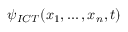<formula> <loc_0><loc_0><loc_500><loc_500>\psi _ { I C T } ( x _ { 1 } , \dots , x _ { n } , t )</formula> 